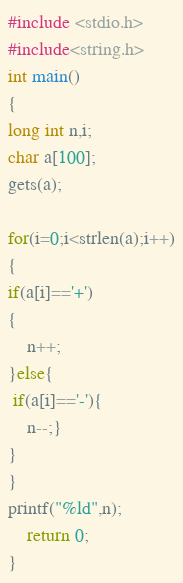Convert code to text. <code><loc_0><loc_0><loc_500><loc_500><_C_>
#include <stdio.h>
#include<string.h>
int main()
{
long int n,i;
char a[100];
gets(a);

for(i=0;i<strlen(a);i++)
{
if(a[i]=='+')
{
    n++;
}else{
 if(a[i]=='-'){
    n--;}
}
}
printf("%ld",n);
    return 0;
}
</code> 